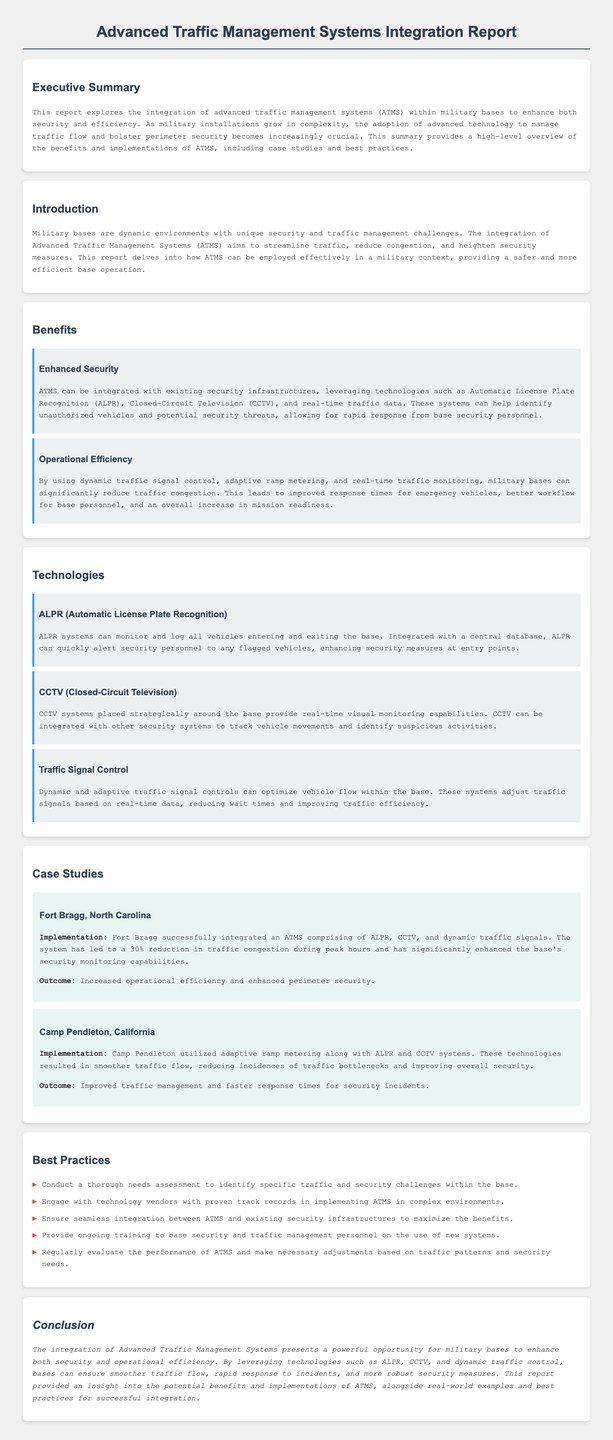what is the primary focus of the report? The primary focus of the report is the integration of advanced traffic management systems (ATMS) within military bases to enhance both security and efficiency.
Answer: integration of advanced traffic management systems (ATMS) what technology is mentioned alongside ALPR for enhancing base security? The report mentions CCTV technology alongside ALPR for enhancing base security.
Answer: CCTV how much reduction in traffic congestion was reported at Fort Bragg? The report states that there was a 30% reduction in traffic congestion during peak hours at Fort Bragg.
Answer: 30% what is one of the best practices for implementing ATMS? One of the best practices mentioned is to conduct a thorough needs assessment to identify specific traffic and security challenges within the base.
Answer: conduct a thorough needs assessment what are the expected outcomes of integrating ATMS as stated in the conclusion? The expected outcomes include smoother traffic flow, rapid response to incidents, and more robust security measures.
Answer: smoother traffic flow, rapid response to incidents, more robust security measures which base successfully implemented adaptive ramp metering? Camp Pendleton, California successfully implemented adaptive ramp metering as part of its ATMS integration.
Answer: Camp Pendleton, California what does ALPR stand for? ALPR stands for Automatic License Plate Recognition.
Answer: Automatic License Plate Recognition what key technology optimizes vehicle flow within the base? The technology that optimizes vehicle flow within the base is dynamic traffic signal control.
Answer: dynamic traffic signal control 